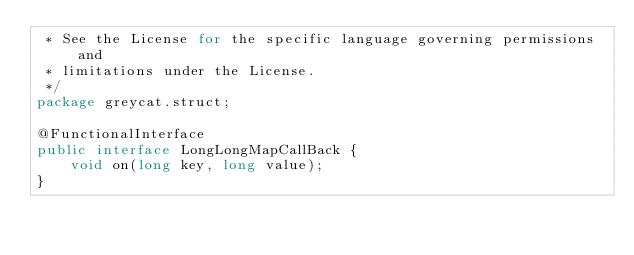<code> <loc_0><loc_0><loc_500><loc_500><_Java_> * See the License for the specific language governing permissions and
 * limitations under the License.
 */
package greycat.struct;

@FunctionalInterface
public interface LongLongMapCallBack {
    void on(long key, long value);
}
</code> 